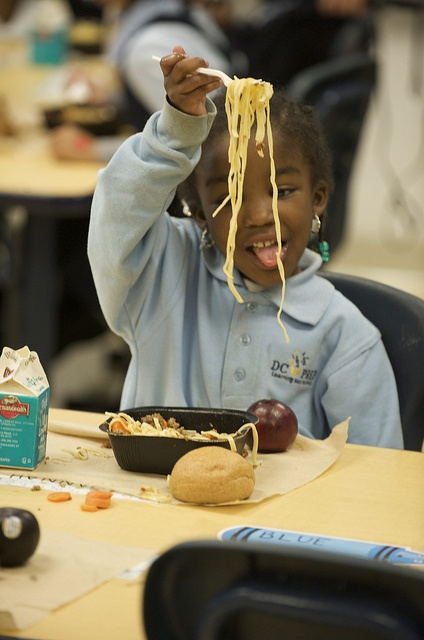Describe the objects in this image and their specific colors. I can see people in maroon, darkgray, gray, and black tones, dining table in maroon, khaki, and tan tones, chair in maroon, black, gray, and darkgray tones, dining table in maroon, black, khaki, and tan tones, and people in maroon, darkgray, gray, lightgray, and tan tones in this image. 